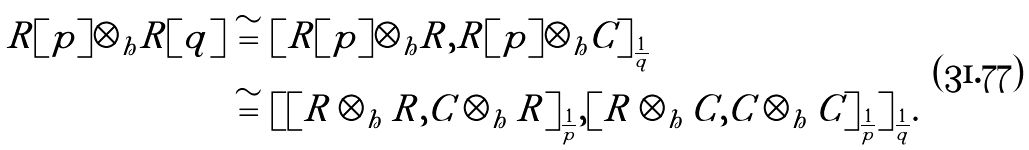Convert formula to latex. <formula><loc_0><loc_0><loc_500><loc_500>R [ p ] \otimes _ { h } R [ q ] & \cong [ R [ p ] \otimes _ { h } R , R [ p ] \otimes _ { h } C ] _ { \frac { 1 } { q } } \\ & \cong [ [ R \otimes _ { h } R , C \otimes _ { h } R ] _ { \frac { 1 } { p } } , [ R \otimes _ { h } C , C \otimes _ { h } C ] _ { \frac { 1 } { p } } ] _ { \frac { 1 } { q } } .</formula> 